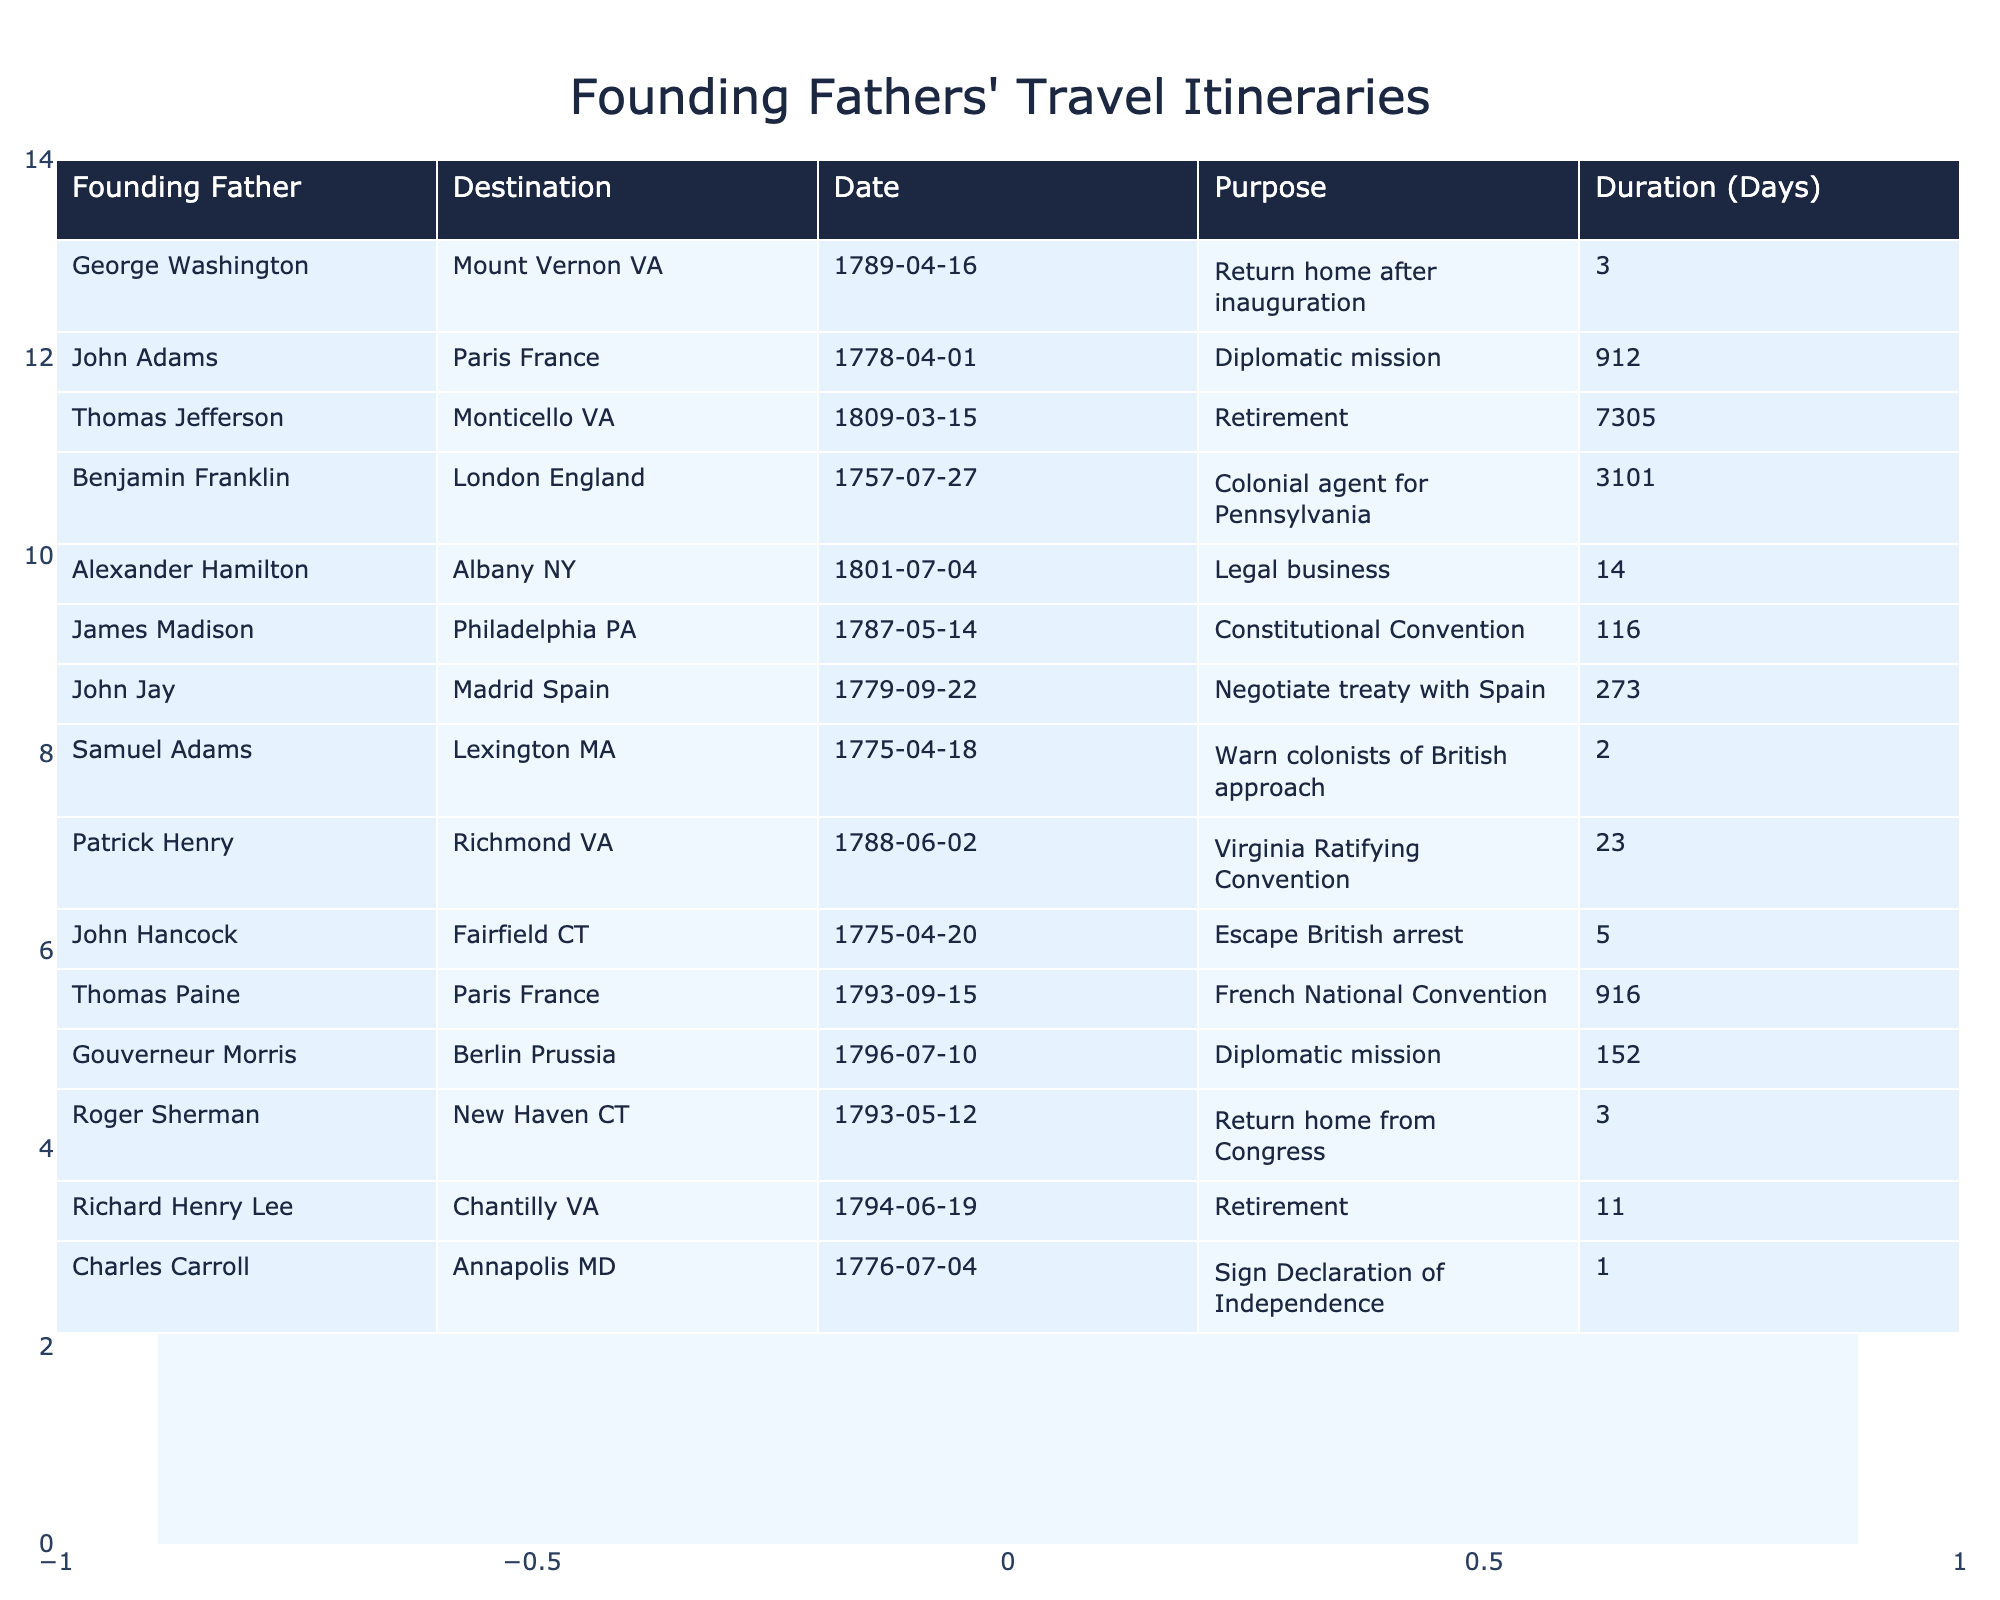What was the destination of John Adams' trip? The table shows that John Adams traveled to Paris, France.
Answer: Paris, France Which Founding Father traveled the longest duration? By reviewing the duration column, Thomas Jefferson's retirement trip lasted 7305 days, which is the longest in the table.
Answer: Thomas Jefferson How many Founding Fathers traveled to foreign countries? A count of the destinations in the table shows that there are four Founding Fathers who traveled to foreign countries: John Adams, Thomas Paine, Gouverneur Morris, and Benjamin Franklin.
Answer: Four What was the purpose of George Washington's travel in April 1789? The table indicates that George Washington's purpose for traveling to Mount Vernon, VA, was to return home after his inauguration.
Answer: Return home after inauguration Which Founding Father had the shortest travel duration? The shortest travel duration listed in the table is 1 day, which corresponds to Charles Carroll's trip to Annapolis, MD.
Answer: Charles Carroll What was the total duration of travel for John Adams and Thomas Paine combined? Adding the travel durations: John Adams in Paris (912 days) and Thomas Paine in Paris (916 days) gives a total of 1828 days.
Answer: 1828 days Did any Founding Father travel for 1000 days or more? A review of the duration column reveals that both John Adams (912 days) and Thomas Paine (916 days) traveled for less than 1000 days, while Benjamin Franklin (3101 days) did.
Answer: Yes What fraction of the listed trips had "Retirement" as their purpose? There are 3 trips with "Retirement" listed (Thomas Jefferson, Richard Henry Lee, and Charles Carroll) out of 14 total trips. The fraction is 3/14.
Answer: 3/14 Which Founding Father visited the most cities according to the table? Each Founding Father traveled to one city listed in the table. Therefore, no Founding Father visited multiple cities according to this data.
Answer: None What is the average duration of travel among all the Founding Fathers listed? To calculate the average, sum all the durations (totaling 10927 days) and divide by the number of trips (14), resulting in an average of approximately 780.5 days.
Answer: 780.5 days 